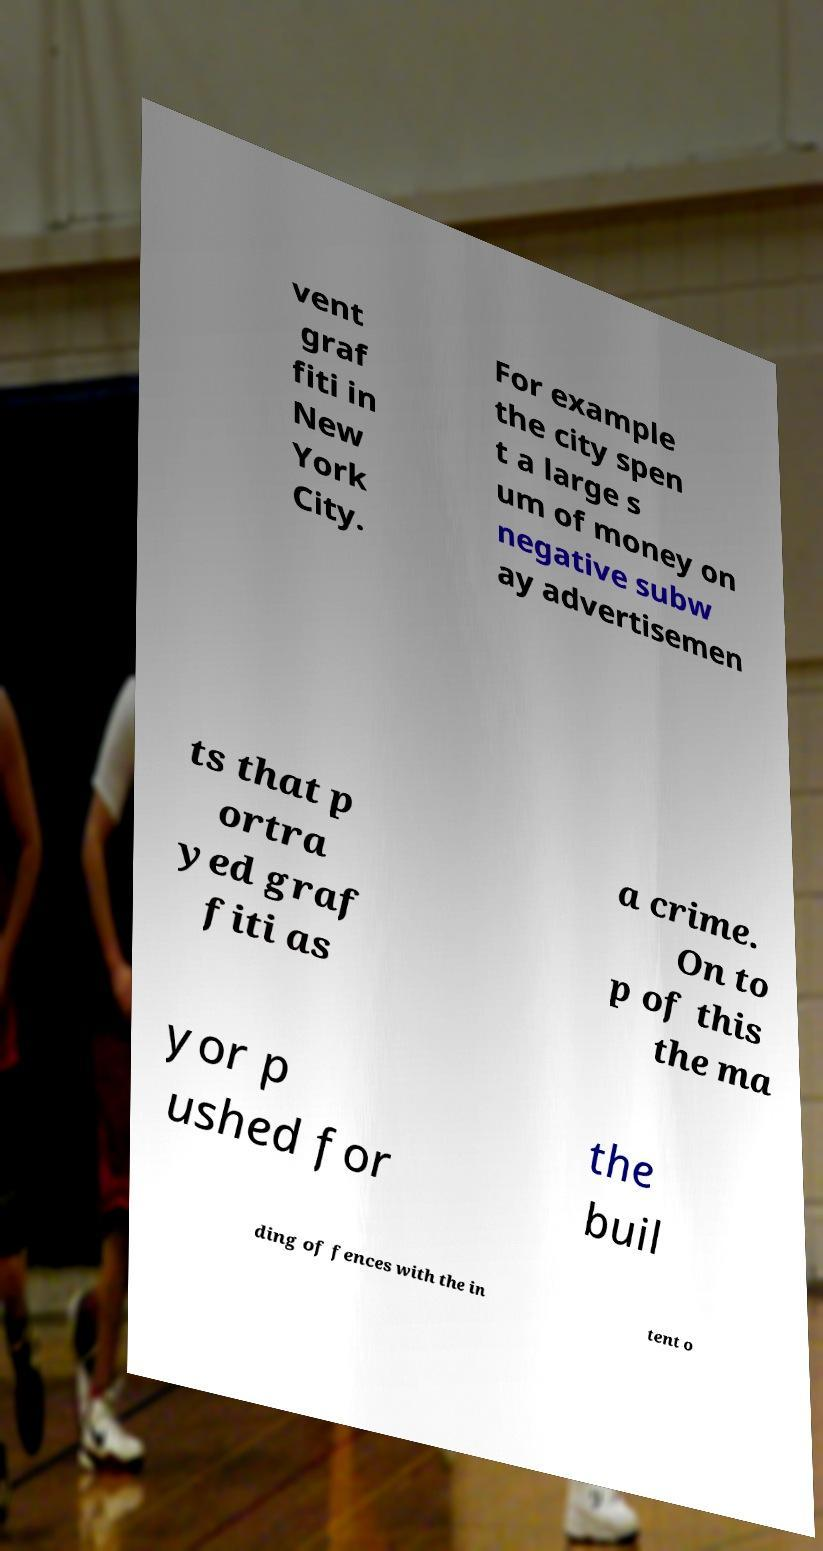What messages or text are displayed in this image? I need them in a readable, typed format. vent graf fiti in New York City. For example the city spen t a large s um of money on negative subw ay advertisemen ts that p ortra yed graf fiti as a crime. On to p of this the ma yor p ushed for the buil ding of fences with the in tent o 